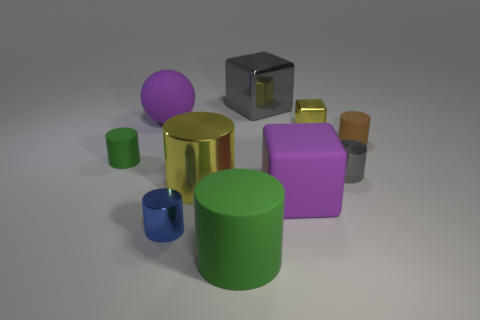Subtract all tiny rubber cylinders. How many cylinders are left? 4 Subtract 1 cylinders. How many cylinders are left? 5 Subtract all purple blocks. How many blocks are left? 2 Add 4 tiny yellow cubes. How many tiny yellow cubes exist? 5 Subtract 1 green cylinders. How many objects are left? 9 Subtract all blocks. How many objects are left? 7 Subtract all brown balls. Subtract all red cylinders. How many balls are left? 1 Subtract all blue cubes. How many gray cylinders are left? 1 Subtract all large matte cylinders. Subtract all small brown rubber things. How many objects are left? 8 Add 2 small brown rubber objects. How many small brown rubber objects are left? 3 